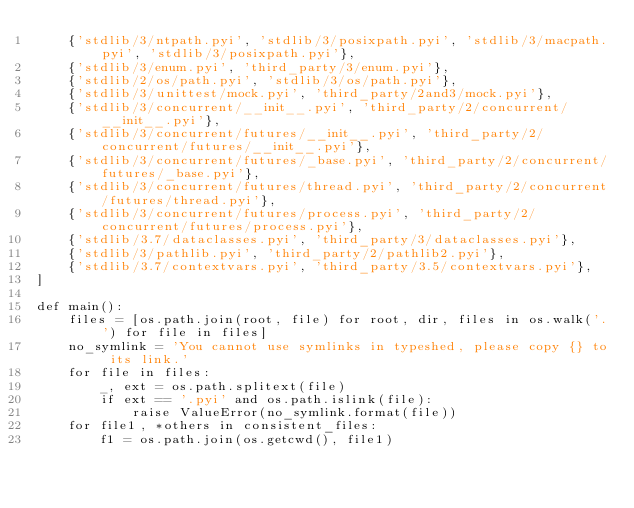Convert code to text. <code><loc_0><loc_0><loc_500><loc_500><_Python_>    {'stdlib/3/ntpath.pyi', 'stdlib/3/posixpath.pyi', 'stdlib/3/macpath.pyi', 'stdlib/3/posixpath.pyi'},
    {'stdlib/3/enum.pyi', 'third_party/3/enum.pyi'},
    {'stdlib/2/os/path.pyi', 'stdlib/3/os/path.pyi'},
    {'stdlib/3/unittest/mock.pyi', 'third_party/2and3/mock.pyi'},
    {'stdlib/3/concurrent/__init__.pyi', 'third_party/2/concurrent/__init__.pyi'},
    {'stdlib/3/concurrent/futures/__init__.pyi', 'third_party/2/concurrent/futures/__init__.pyi'},
    {'stdlib/3/concurrent/futures/_base.pyi', 'third_party/2/concurrent/futures/_base.pyi'},
    {'stdlib/3/concurrent/futures/thread.pyi', 'third_party/2/concurrent/futures/thread.pyi'},
    {'stdlib/3/concurrent/futures/process.pyi', 'third_party/2/concurrent/futures/process.pyi'},
    {'stdlib/3.7/dataclasses.pyi', 'third_party/3/dataclasses.pyi'},
    {'stdlib/3/pathlib.pyi', 'third_party/2/pathlib2.pyi'},
    {'stdlib/3.7/contextvars.pyi', 'third_party/3.5/contextvars.pyi'},
]

def main():
    files = [os.path.join(root, file) for root, dir, files in os.walk('.') for file in files]
    no_symlink = 'You cannot use symlinks in typeshed, please copy {} to its link.'
    for file in files:
        _, ext = os.path.splitext(file)
        if ext == '.pyi' and os.path.islink(file):
            raise ValueError(no_symlink.format(file))
    for file1, *others in consistent_files:
        f1 = os.path.join(os.getcwd(), file1)</code> 